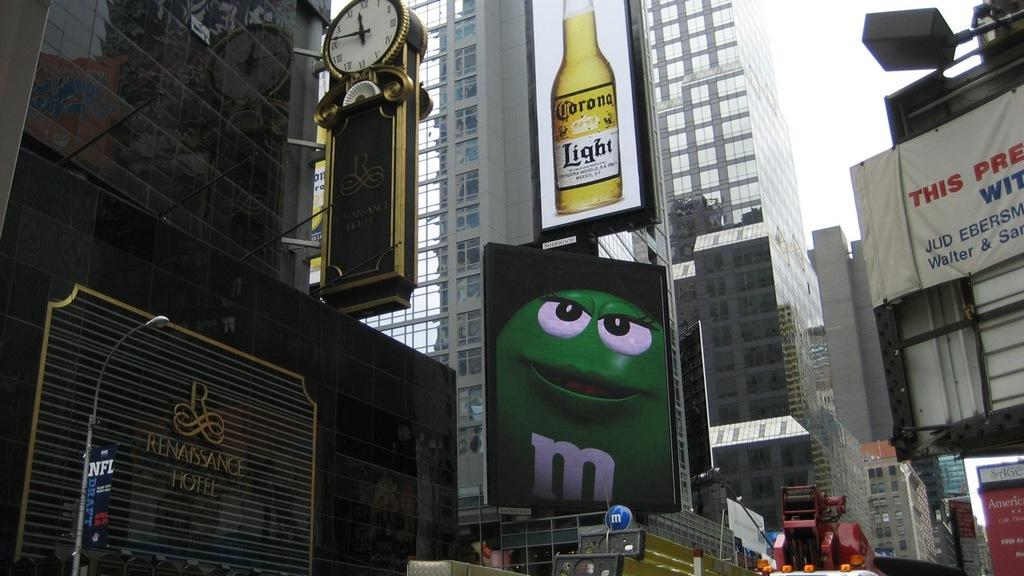<image>
Summarize the visual content of the image. A bunch of billboards in a city including one advertising Corona light 